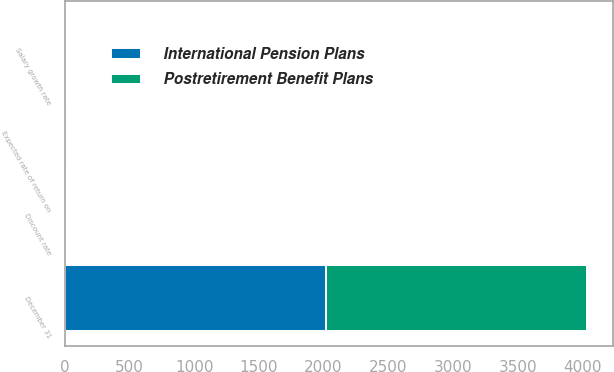Convert chart to OTSL. <chart><loc_0><loc_0><loc_500><loc_500><stacked_bar_chart><ecel><fcel>December 31<fcel>Discount rate<fcel>Expected rate of return on<fcel>Salary growth rate<nl><fcel>Postretirement Benefit Plans<fcel>2016<fcel>4.7<fcel>8.6<fcel>4.3<nl><fcel>International Pension Plans<fcel>2016<fcel>2.8<fcel>5.6<fcel>2.9<nl></chart> 